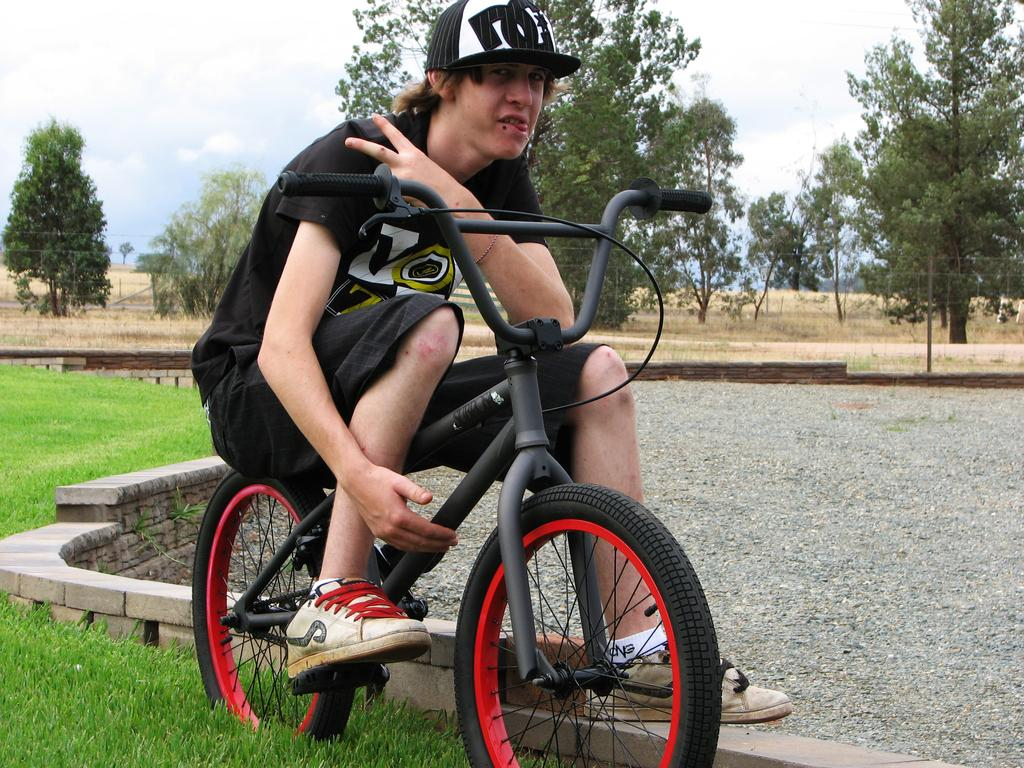Who is present in the image? There is a man in the image. What is the man doing in the image? The man is seated on a bicycle. What is the man wearing on his head? The man is wearing a cap. What type of terrain is visible in the image? There is grass on the ground in the image. What other natural elements can be seen in the image? There are trees visible in the image. How would you describe the weather in the image? The sky is cloudy in the image. Can you hear the clam crying in the image? There is no clam or crying sound present in the image. 